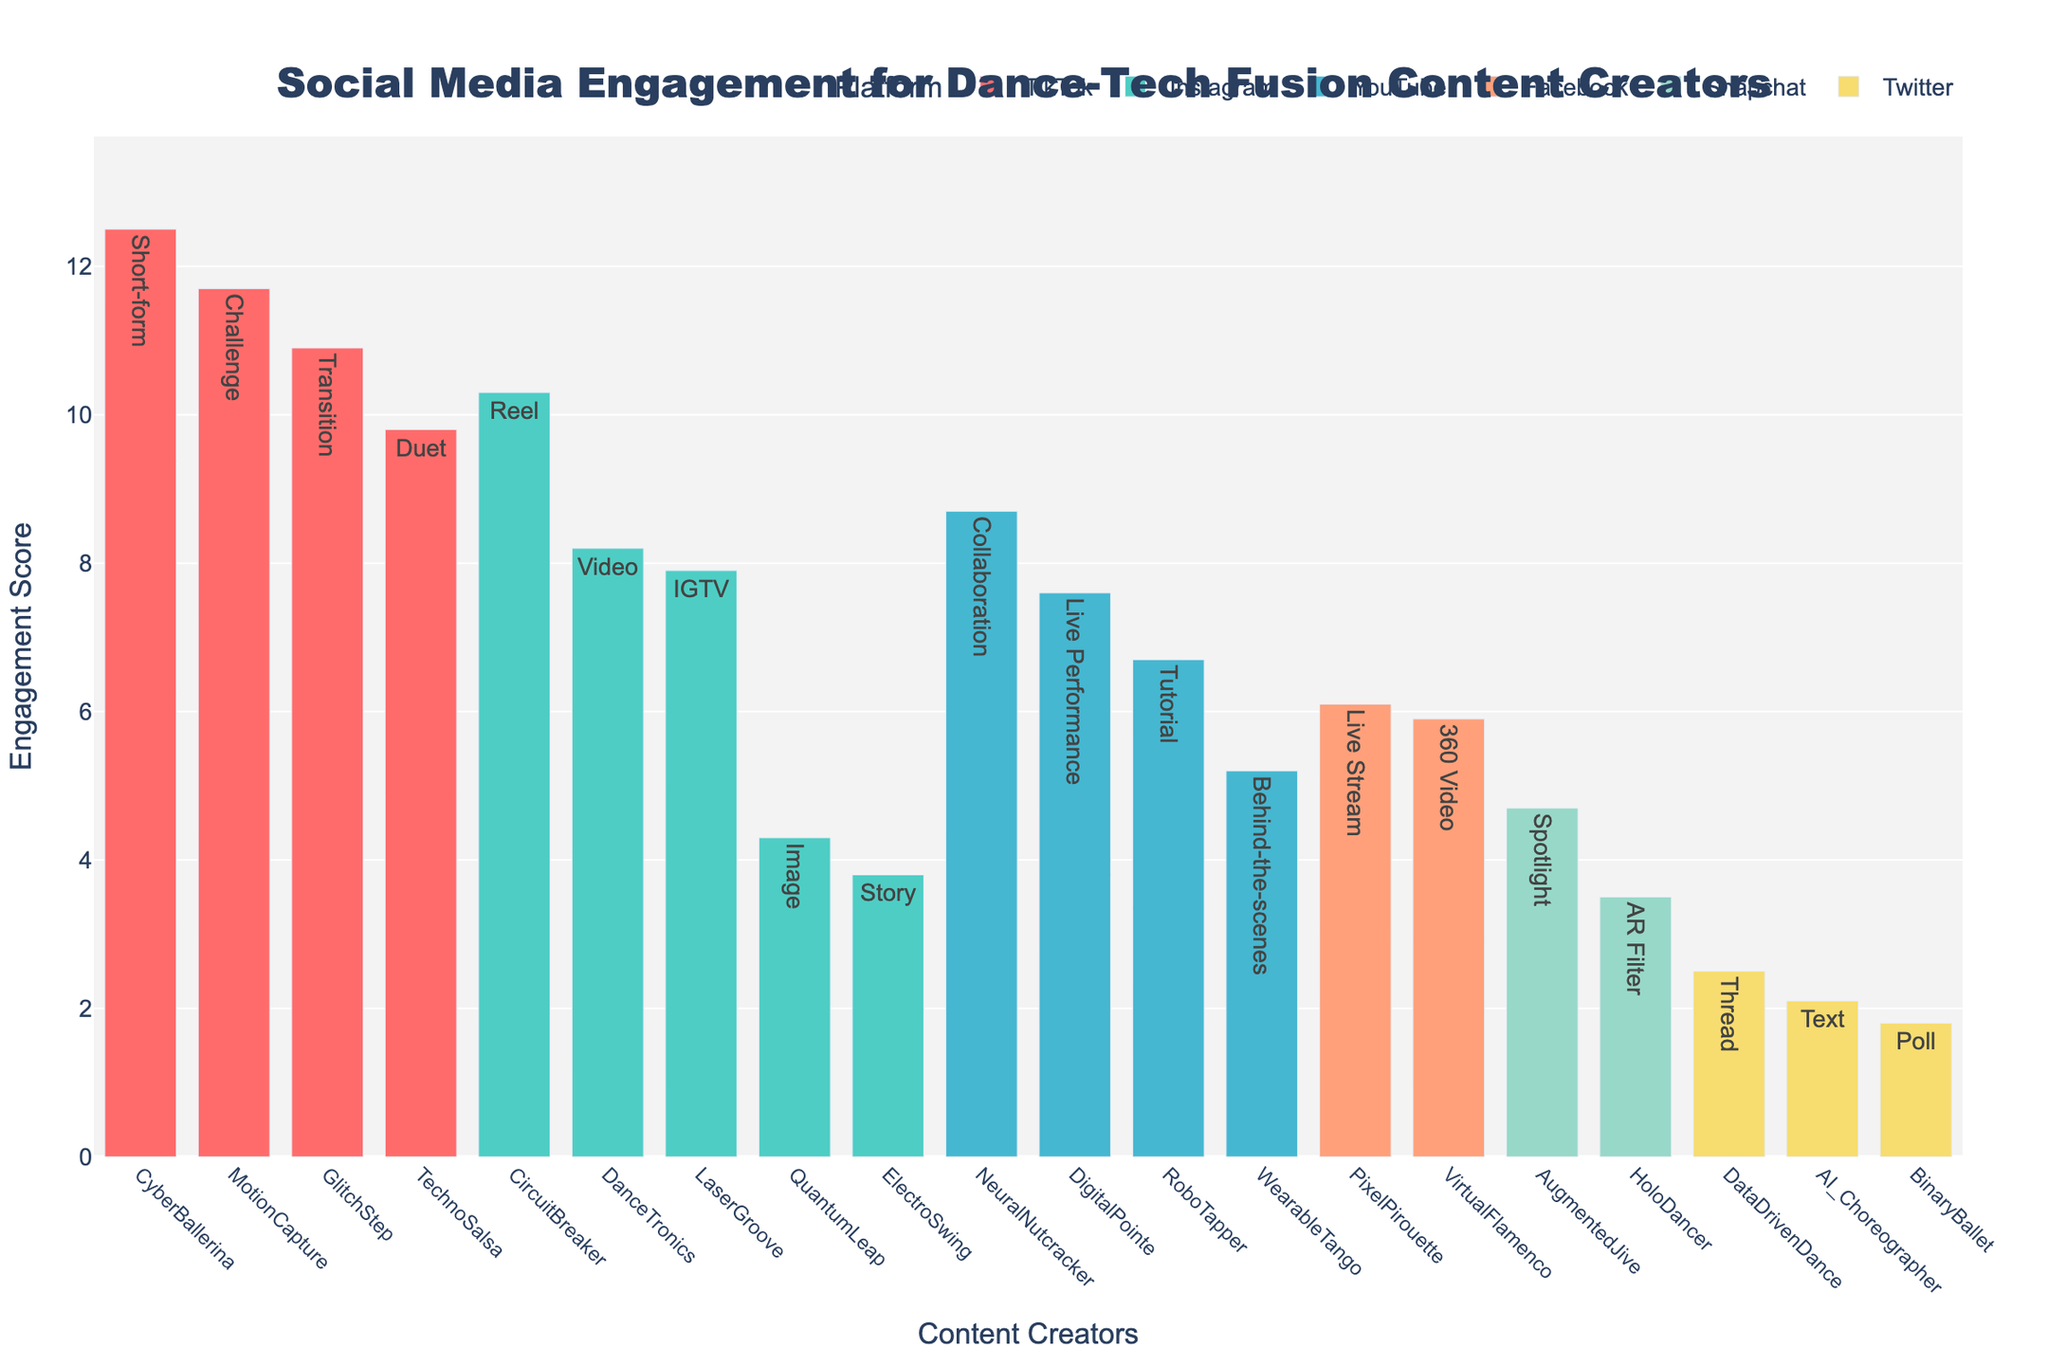What's the highest engagement score recorded and by which creator? Look for the bar with the highest value on the y-axis. The highest engagement score is 12.5, attributed to CyberBallerina.
Answer: 12.5, CyberBallerina Which platform features the most varied post types across content creators? Count the unique post types listed for each platform indicated by different colors. TikTok has Short-form, Duet, Challenge, and Transition, making it the most varied.
Answer: TikTok Between Instagram Reels and IGTV, which post type has a higher engagement score and by how much? Compare the engagement scores for Reels and IGTV. Reels are at 10.3, and IGTV is at 7.9. Subtract IGTV's score from Reels' score: 10.3 - 7.9 = 2.4.
Answer: Reels, 2.4 Rank the platforms from highest average engagement score to the lowest. Calculate the average engagement score for each platform by summing the scores and dividing by the number of entries. TikTok (average 11.225), Instagram (average 6.1), YouTube (average 7.05), Facebook (average 6.0), Snapchat (average 4.1), Twitter (average 2.13).
Answer: TikTok, YouTube, Facebook, Instagram, Snapchat, Twitter What is the engagement score difference between the YouTube Tutorial and the YouTube Collaboration post types? Look at the bars corresponding to YouTube and find the Tutorial and Collaboration post types. Tutorial is 6.7, and Collaboration is 8.7. The difference is 8.7 - 6.7 = 2.
Answer: 2 Which content creator on Instagram has the lowest engagement score, and what is it? For Instagram (one of the colors), identify the lowest bar. The lowest engagement score is 3.8 by ElectroSwing.
Answer: ElectroSwing, 3.8 Would you say that short-form videos on TikTok generally have higher engagement compared to longer-format videos on YouTube? Look at the engagement scores for TikTok Short-form (12.5) and compare it with YouTube's longer-format scores, which are generally between 5.2 and 8.7. TikTok's Short-form has higher scores.
Answer: Yes How many creators have an engagement score greater than 10? Count the bars with y-values (Engagement Scores) greater than 10. There are 5 creators: CyberBallerina, TechnoSalsa, CircuitBreaker, MotionCapture, GlitchStep.
Answer: 5 What is the engagement score range for Facebook's content contributors? Find the highest and lowest engagement scores for Facebook. The highest is 6.1 (Live Stream) and the lowest is 5.9 (360 Video). The range is 6.1 - 5.9 = 0.2.
Answer: 0.2 Which TikTok post type achieves the second highest engagement score, and what is the value? Find TikTok post types on the plot and order their engagement scores: Short-form (12.5), Transition (10.9), Challenge (11.7), Duet (9.8). The second highest is Transition with 10.9.
Answer: Transition, 10.9 